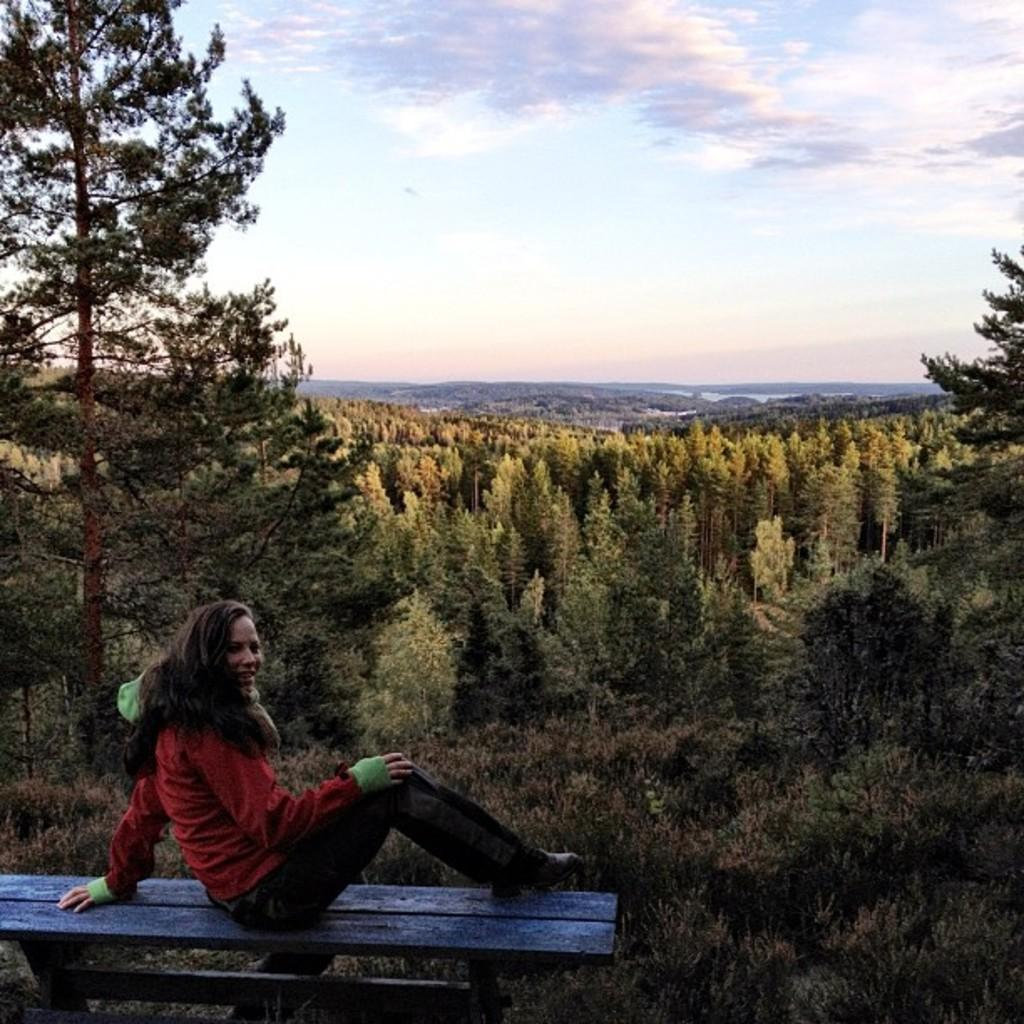Who is present in the image? There is a woman in the image. What is the woman wearing? The woman is wearing a red sweater. Where is the woman sitting? The woman is sitting on a wooden bench. What is the woman's facial expression? The woman is smiling. What can be seen in the background of the image? There are trees, water, and the sky visible in the background. What is the condition of the sky? Clouds are present in the sky. What type of cherries can be seen floating in the soda in the image? There is no soda or cherries present in the image. 